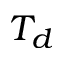<formula> <loc_0><loc_0><loc_500><loc_500>T _ { d }</formula> 